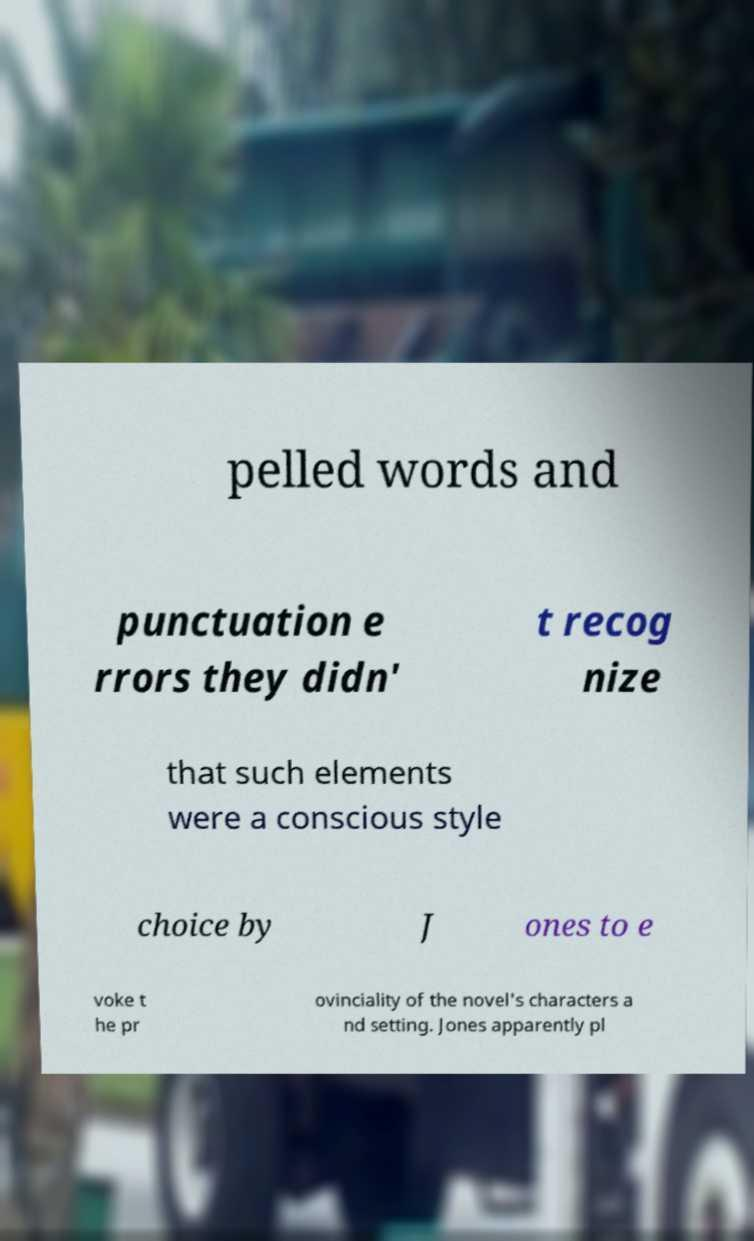Please read and relay the text visible in this image. What does it say? pelled words and punctuation e rrors they didn' t recog nize that such elements were a conscious style choice by J ones to e voke t he pr ovinciality of the novel's characters a nd setting. Jones apparently pl 